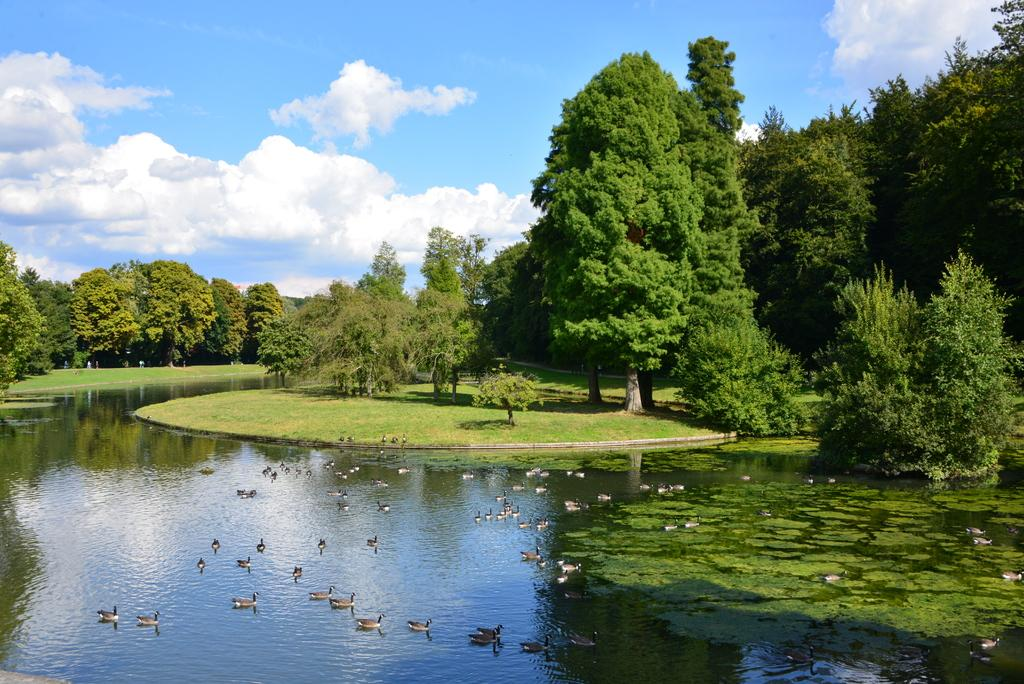What type of animals can be seen in the water in the image? There are many ducks in the water in the image. What is visible in the image besides the ducks? The water, grass, plants, trees, and sky are visible in the image. What is the color and condition of the sky in the image? The sky is cloudy and pale blue in the image. What type of needle can be seen in the image? There is no needle present in the image. What is the tail of the duck doing in the image? There is no duck's tail movement mentioned or visible in the image. 